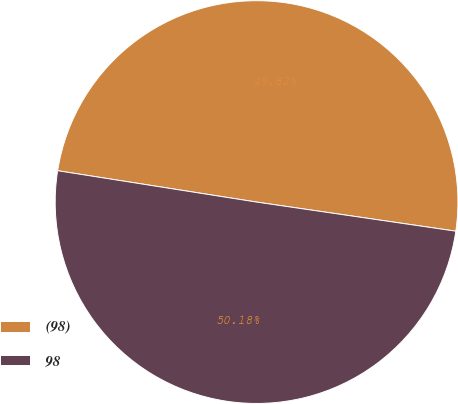<chart> <loc_0><loc_0><loc_500><loc_500><pie_chart><fcel>(98)<fcel>98<nl><fcel>49.82%<fcel>50.18%<nl></chart> 